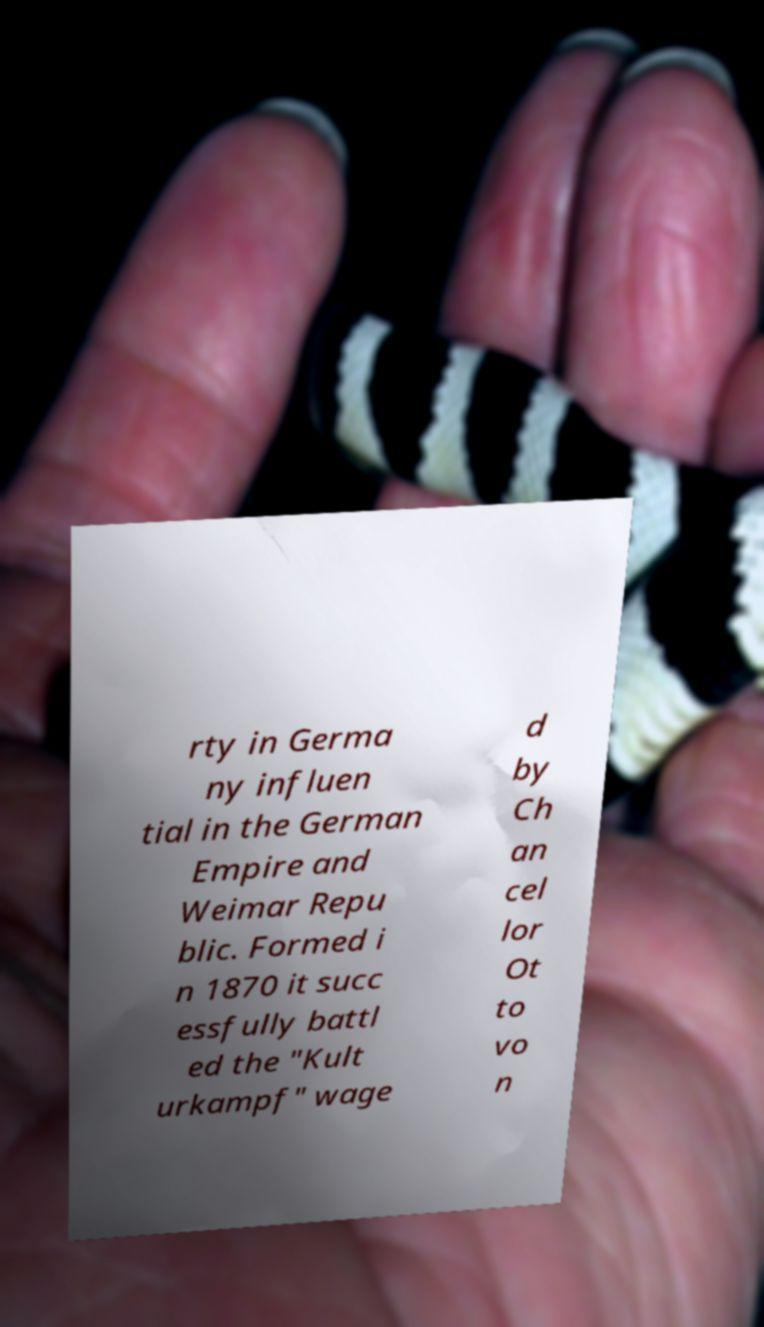What messages or text are displayed in this image? I need them in a readable, typed format. rty in Germa ny influen tial in the German Empire and Weimar Repu blic. Formed i n 1870 it succ essfully battl ed the "Kult urkampf" wage d by Ch an cel lor Ot to vo n 